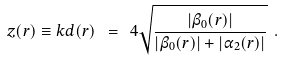<formula> <loc_0><loc_0><loc_500><loc_500>z ( { r } ) \equiv k d ( { r } ) \ = \ 4 \sqrt { \frac { | \beta _ { 0 } ( { r } ) | } { | \beta _ { 0 } ( { r } ) | + | \alpha _ { 2 } ( { r } ) | } } \ .</formula> 